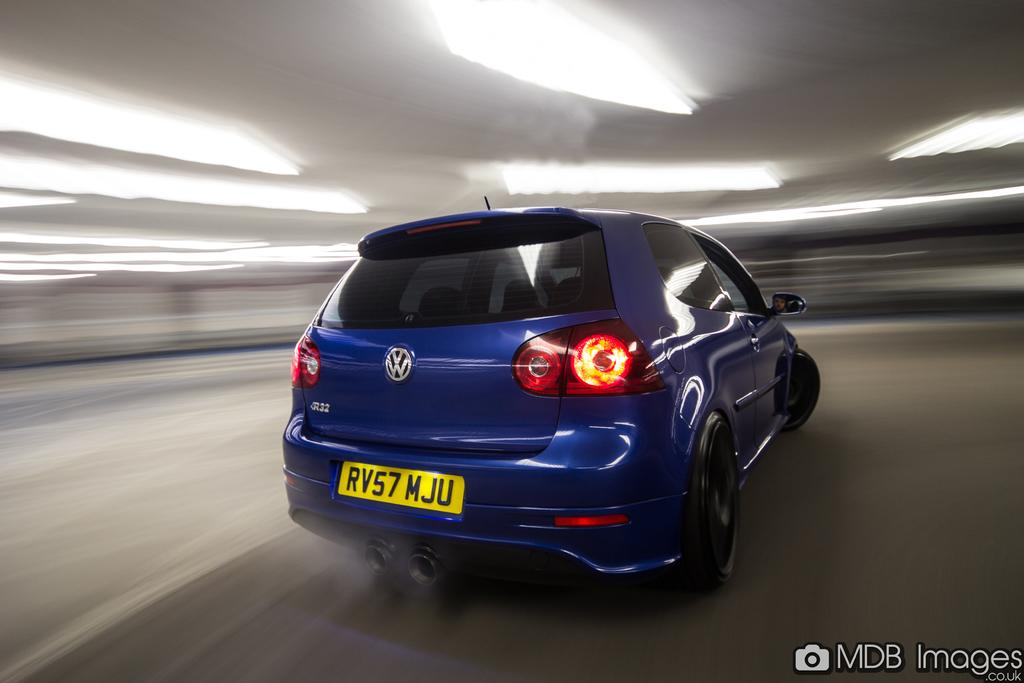What type of car is in the image? There is a blue color Volkswagen car in the image. What color is the number plate on the car? The number plate on the car is yellow color. What type of lead can be seen in the image? There is no lead present in the image; it features a blue Volkswagen car with a yellow number plate. What type of oven is visible in the image? There is no oven present in the image. 